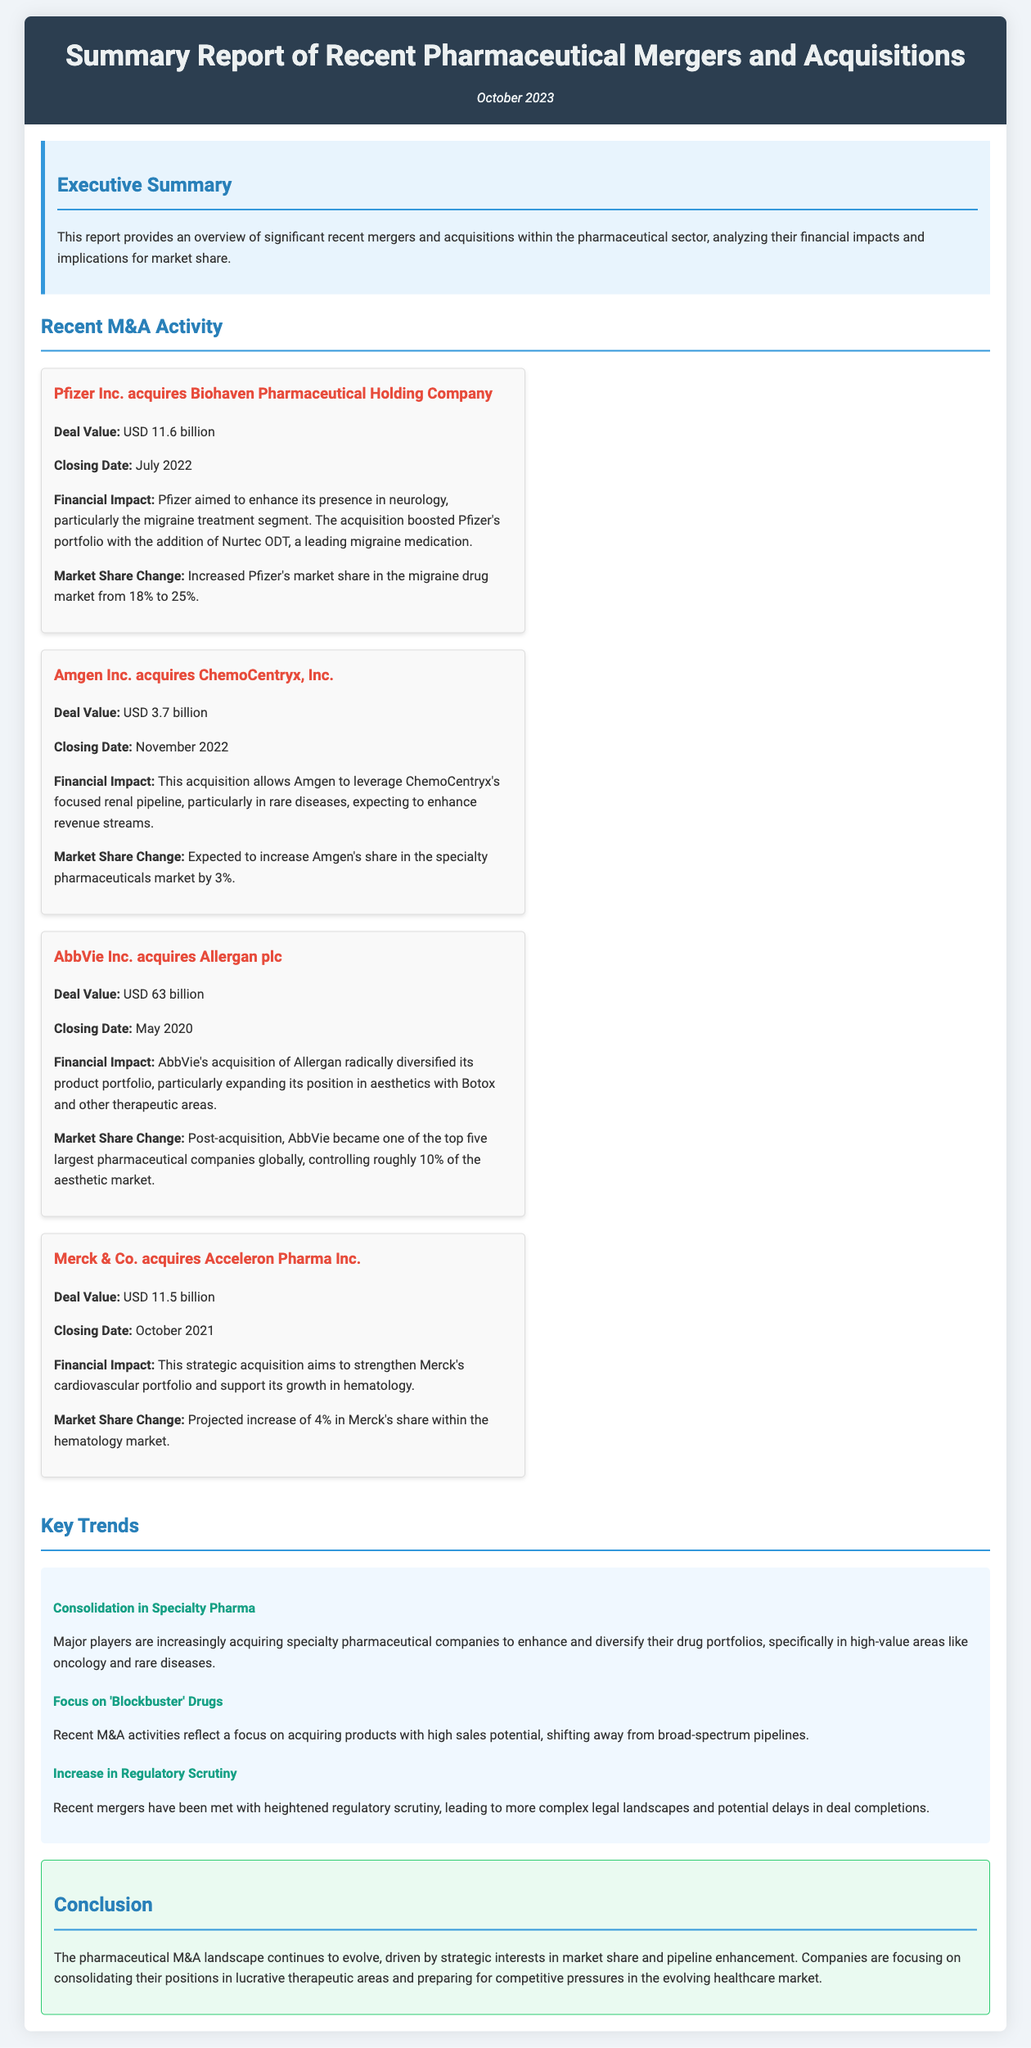What is the total deal value of the Pfizer acquisition? The deal value for Pfizer's acquisition of Biohaven Pharmaceutical is listed as USD 11.6 billion.
Answer: USD 11.6 billion When did AbbVie acquire Allergan? The closing date for AbbVie's acquisition of Allergan is stated as May 2020.
Answer: May 2020 What percentage did Pfizer's market share in the migraine drug market increase to? The document mentions that Pfizer increased its market share in the migraine drug market to 25%.
Answer: 25% What financial impact did Amgen expect from the acquisition of ChemoCentryx? The financial impact is expected to enhance revenue streams for Amgen through leveraging ChemoCentryx's focused renal pipeline.
Answer: Enhance revenue streams What is a key trend mentioned regarding specialty pharmaceuticals? One key trend is the consolidation in specialty pharmaceuticals, enhancing and diversifying drug portfolios.
Answer: Consolidation in Specialty Pharma What is the projected increase in Merck's market share in the hematology market? The document indicates a projected increase of 4% in Merck's market share in the hematology market.
Answer: 4% What is highlighted as a focus in recent M&A activities? The focus in recent M&A activities reflects an emphasis on acquiring products with high sales potential.
Answer: Focus on 'Blockbuster' Drugs What document type does this report represent? This report is a summary of recent mergers and acquisitions in the pharmaceutical sector.
Answer: Summary report 